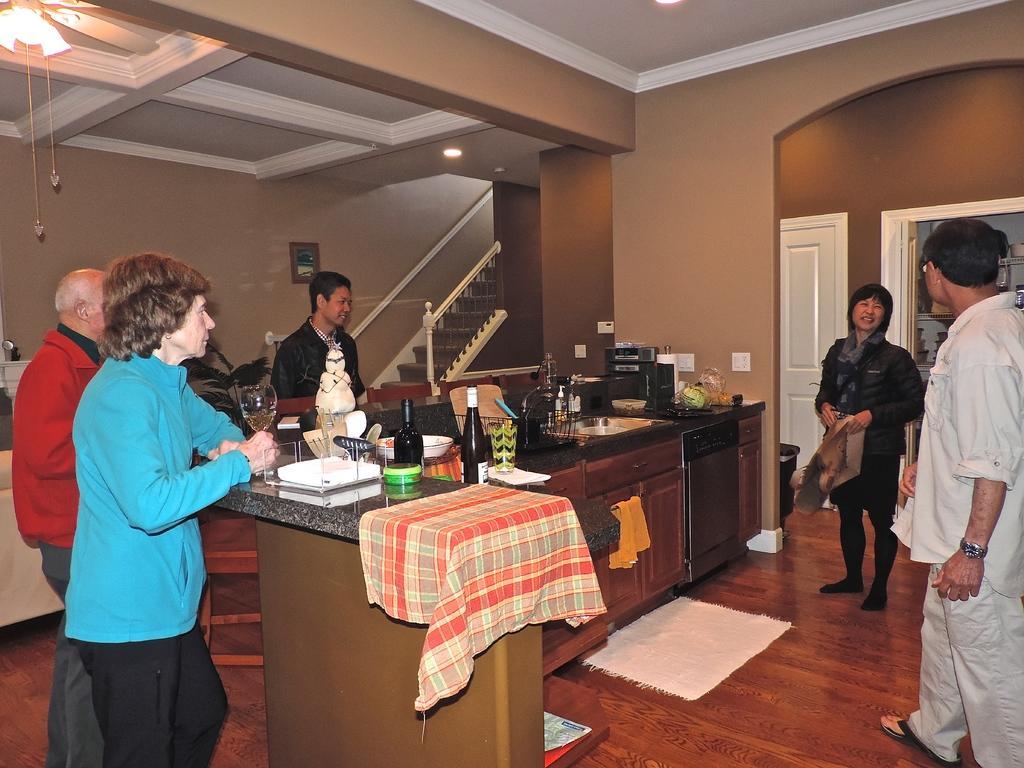Can you describe this image briefly? In the center of the image there is a counter table and we can see bottles, sink, holder, cloth and some objects placed on the counter table. There is a floor mat placed on the floor. We can see people standing. In the background there are stairs and doors. At the top there are lights. We can see a frame placed on the wall. 